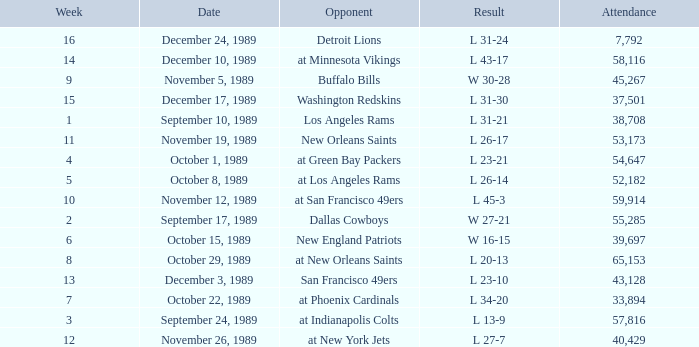On September 10, 1989 how many people attended the game? 38708.0. 